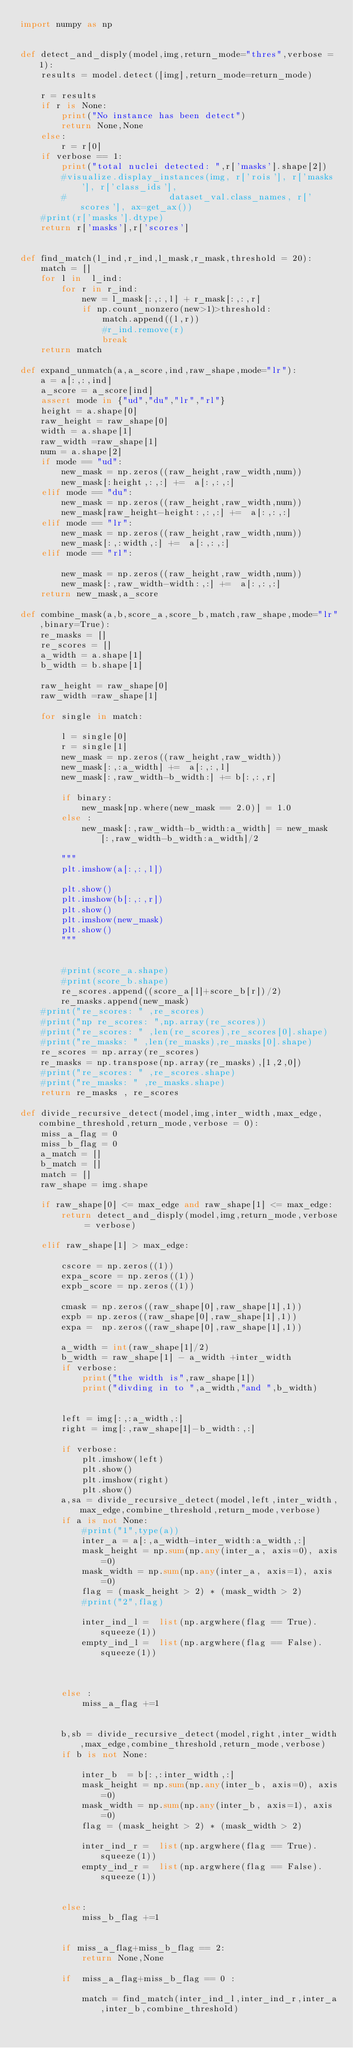Convert code to text. <code><loc_0><loc_0><loc_500><loc_500><_Python_>import numpy as np


def detect_and_disply(model,img,return_mode="thres",verbose = 1):
    results = model.detect([img],return_mode=return_mode)

    r = results
    if r is None:
        print("No instance has been detect")
        return None,None
    else:
        r = r[0]
    if verbose == 1:
        print("total nuclei detected: ",r['masks'].shape[2])
        #visualize.display_instances(img, r['rois'], r['masks'], r['class_ids'], 
        #                    dataset_val.class_names, r['scores'], ax=get_ax())
    #print(r['masks'].dtype)
    return r['masks'],r['scores']


def find_match(l_ind,r_ind,l_mask,r_mask,threshold = 20):
    match = []
    for l in  l_ind:
        for r in r_ind:
            new = l_mask[:,:,l] + r_mask[:,:,r]
            if np.count_nonzero(new>1)>threshold:
                match.append((l,r))
                #r_ind.remove(r)
                break
    return match   

def expand_unmatch(a,a_score,ind,raw_shape,mode="lr"):
    a = a[:,:,ind]
    a_score = a_score[ind]
    assert mode in {"ud","du","lr","rl"}
    height = a.shape[0]
    raw_height = raw_shape[0]
    width = a.shape[1]
    raw_width =raw_shape[1]
    num = a.shape[2]
    if mode == "ud":
        new_mask = np.zeros((raw_height,raw_width,num))
        new_mask[:height,:,:] +=  a[:,:,:]
    elif mode == "du":
        new_mask = np.zeros((raw_height,raw_width,num))
        new_mask[raw_height-height:,:,:] +=  a[:,:,:]
    elif mode == "lr":
        new_mask = np.zeros((raw_height,raw_width,num))
        new_mask[:,:width,:] +=  a[:,:,:]
    elif mode == "rl":

        new_mask = np.zeros((raw_height,raw_width,num))
        new_mask[:,raw_width-width:,:] +=  a[:,:,:]
    return new_mask,a_score

def combine_mask(a,b,score_a,score_b,match,raw_shape,mode="lr",binary=True):
    re_masks = []
    re_scores = []
    a_width = a.shape[1]
    b_width = b.shape[1]
    
    raw_height = raw_shape[0]
    raw_width =raw_shape[1]
    
    for single in match:
    
        l = single[0]
        r = single[1]
        new_mask = np.zeros((raw_height,raw_width))
        new_mask[:,:a_width] +=  a[:,:,l]
        new_mask[:,raw_width-b_width:] += b[:,:,r]

        if binary:
            new_mask[np.where(new_mask == 2.0)] = 1.0
        else :
            new_mask[:,raw_width-b_width:a_width] = new_mask[:,raw_width-b_width:a_width]/2
            
        """
        plt.imshow(a[:,:,l])
        
        plt.show()
        plt.imshow(b[:,:,r])
        plt.show()
        plt.imshow(new_mask)
        plt.show()
        """

        
        #print(score_a.shape)
        #print(score_b.shape)
        re_scores.append((score_a[l]+score_b[r])/2)
        re_masks.append(new_mask)
    #print("re_scores: " ,re_scores)
    #print("np re_scores: ",np.array(re_scores))
    #print("re_scores: " ,len(re_scores),re_scores[0].shape)
    #print("re_masks: " ,len(re_masks),re_masks[0].shape)    
    re_scores = np.array(re_scores)
    re_masks = np.transpose(np.array(re_masks),[1,2,0])
    #print("re_scores: " ,re_scores.shape)
    #print("re_masks: " ,re_masks.shape)
    return re_masks , re_scores

def divide_recursive_detect(model,img,inter_width,max_edge,combine_threshold,return_mode,verbose = 0):
    miss_a_flag = 0
    miss_b_flag = 0
    a_match = []
    b_match = []
    match = []
    raw_shape = img.shape
    
    if raw_shape[0] <= max_edge and raw_shape[1] <= max_edge:
        return detect_and_disply(model,img,return_mode,verbose = verbose)
    
    elif raw_shape[1] > max_edge:

        cscore = np.zeros((1))
        expa_score = np.zeros((1))
        expb_score = np.zeros((1))
        
        cmask = np.zeros((raw_shape[0],raw_shape[1],1))
        expb = np.zeros((raw_shape[0],raw_shape[1],1))
        expa =  np.zeros((raw_shape[0],raw_shape[1],1))
    
        a_width = int(raw_shape[1]/2)
        b_width = raw_shape[1] - a_width +inter_width
        if verbose:
            print("the width is",raw_shape[1])
            print("divding in to ",a_width,"and ",b_width)
            

        left = img[:,:a_width,:]
        right = img[:,raw_shape[1]-b_width:,:]
        
        if verbose:
            plt.imshow(left)
            plt.show()
            plt.imshow(right)
            plt.show()
        a,sa = divide_recursive_detect(model,left,inter_width,max_edge,combine_threshold,return_mode,verbose)
        if a is not None:
            #print("1",type(a))
            inter_a = a[:,a_width-inter_width:a_width,:]
            mask_height = np.sum(np.any(inter_a, axis=0), axis=0)
            mask_width = np.sum(np.any(inter_a, axis=1), axis=0)
            flag = (mask_height > 2) * (mask_width > 2) 
            #print("2",flag)
    
            inter_ind_l =  list(np.argwhere(flag == True).squeeze(1))
            empty_ind_l =  list(np.argwhere(flag == False).squeeze(1))



        else :
            miss_a_flag +=1
        

        b,sb = divide_recursive_detect(model,right,inter_width,max_edge,combine_threshold,return_mode,verbose)
        if b is not None:

            inter_b  = b[:,:inter_width,:]
            mask_height = np.sum(np.any(inter_b, axis=0), axis=0)
            mask_width = np.sum(np.any(inter_b, axis=1), axis=0)
            flag = (mask_height > 2) * (mask_width > 2) 
    
            inter_ind_r =  list(np.argwhere(flag == True).squeeze(1))
            empty_ind_r =  list(np.argwhere(flag == False).squeeze(1))


        else:
            miss_b_flag +=1
            
            
        if miss_a_flag+miss_b_flag == 2:
            return None,None
        
        if  miss_a_flag+miss_b_flag == 0 :
            
            match = find_match(inter_ind_l,inter_ind_r,inter_a,inter_b,combine_threshold)</code> 